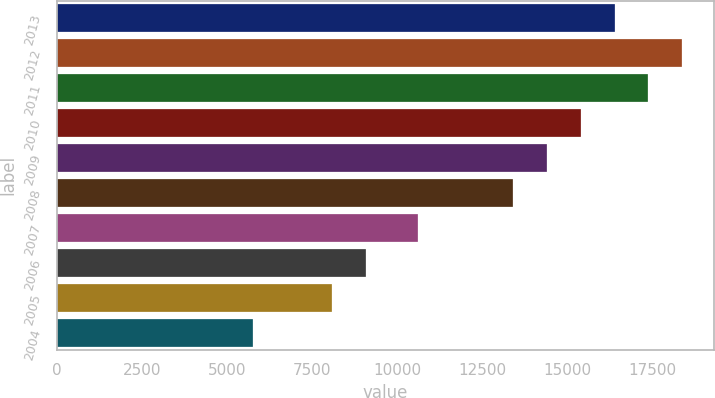Convert chart to OTSL. <chart><loc_0><loc_0><loc_500><loc_500><bar_chart><fcel>2013<fcel>2012<fcel>2011<fcel>2010<fcel>2009<fcel>2008<fcel>2007<fcel>2006<fcel>2005<fcel>2004<nl><fcel>16390.6<fcel>18377<fcel>17383.8<fcel>15397.4<fcel>14404.2<fcel>13411<fcel>10613<fcel>9095.2<fcel>8102<fcel>5763<nl></chart> 